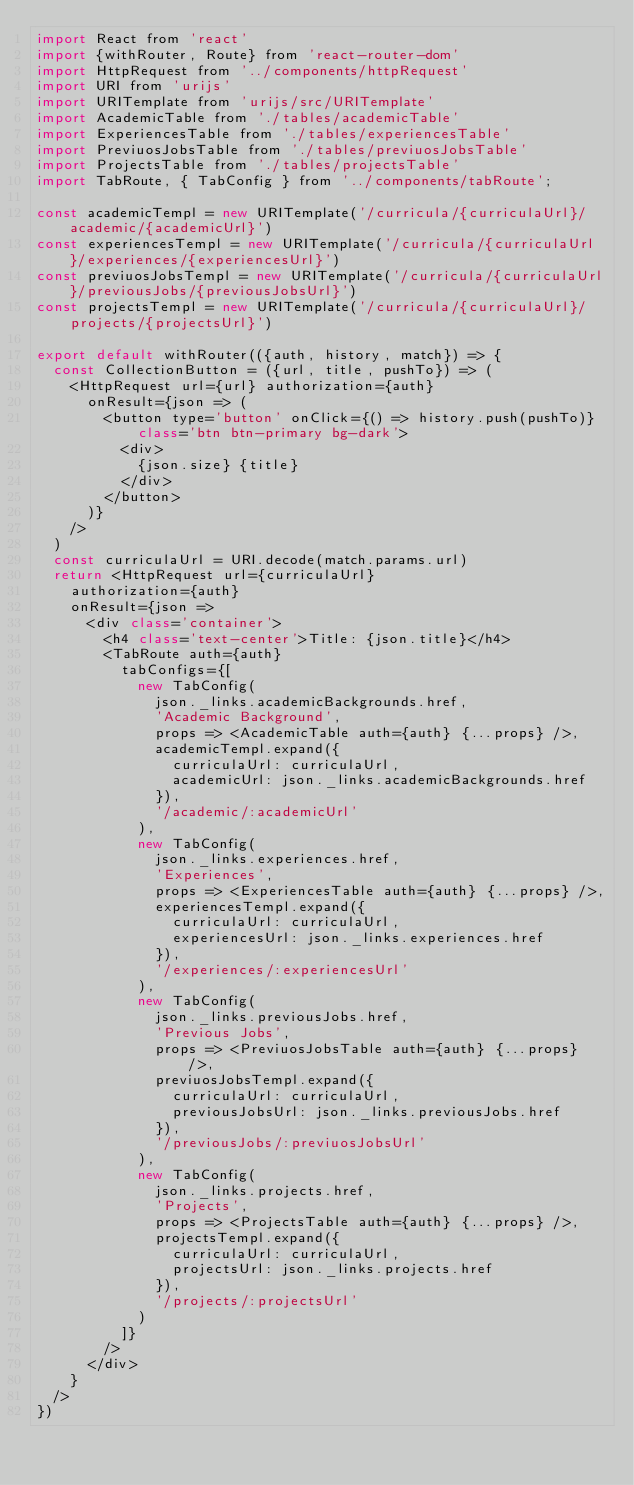Convert code to text. <code><loc_0><loc_0><loc_500><loc_500><_JavaScript_>import React from 'react'
import {withRouter, Route} from 'react-router-dom'
import HttpRequest from '../components/httpRequest'
import URI from 'urijs'
import URITemplate from 'urijs/src/URITemplate'
import AcademicTable from './tables/academicTable'
import ExperiencesTable from './tables/experiencesTable'
import PreviuosJobsTable from './tables/previuosJobsTable'
import ProjectsTable from './tables/projectsTable'
import TabRoute, { TabConfig } from '../components/tabRoute';

const academicTempl = new URITemplate('/curricula/{curriculaUrl}/academic/{academicUrl}')
const experiencesTempl = new URITemplate('/curricula/{curriculaUrl}/experiences/{experiencesUrl}')
const previuosJobsTempl = new URITemplate('/curricula/{curriculaUrl}/previousJobs/{previousJobsUrl}')
const projectsTempl = new URITemplate('/curricula/{curriculaUrl}/projects/{projectsUrl}')

export default withRouter(({auth, history, match}) => {
  const CollectionButton = ({url, title, pushTo}) => (
    <HttpRequest url={url} authorization={auth}
      onResult={json => (
        <button type='button' onClick={() => history.push(pushTo)} class='btn btn-primary bg-dark'>
          <div>
            {json.size} {title}
          </div>
        </button>
      )}
    />
  )
  const curriculaUrl = URI.decode(match.params.url)
  return <HttpRequest url={curriculaUrl}
    authorization={auth}
    onResult={json =>
      <div class='container'>
        <h4 class='text-center'>Title: {json.title}</h4>
        <TabRoute auth={auth}
          tabConfigs={[
            new TabConfig(
              json._links.academicBackgrounds.href,
              'Academic Background',
              props => <AcademicTable auth={auth} {...props} />,
              academicTempl.expand({
                curriculaUrl: curriculaUrl,
                academicUrl: json._links.academicBackgrounds.href
              }),
              '/academic/:academicUrl'
            ),
            new TabConfig(
              json._links.experiences.href,
              'Experiences',
              props => <ExperiencesTable auth={auth} {...props} />,
              experiencesTempl.expand({
                curriculaUrl: curriculaUrl,
                experiencesUrl: json._links.experiences.href
              }),
              '/experiences/:experiencesUrl'
            ),
            new TabConfig(
              json._links.previousJobs.href,
              'Previous Jobs',
              props => <PreviuosJobsTable auth={auth} {...props} />,
              previuosJobsTempl.expand({
                curriculaUrl: curriculaUrl,
                previousJobsUrl: json._links.previousJobs.href
              }),
              '/previousJobs/:previuosJobsUrl'
            ),
            new TabConfig(
              json._links.projects.href,
              'Projects',
              props => <ProjectsTable auth={auth} {...props} />,
              projectsTempl.expand({
                curriculaUrl: curriculaUrl,
                projectsUrl: json._links.projects.href
              }),
              '/projects/:projectsUrl'
            )
          ]}
        />
      </div>
    }
  />
})
</code> 